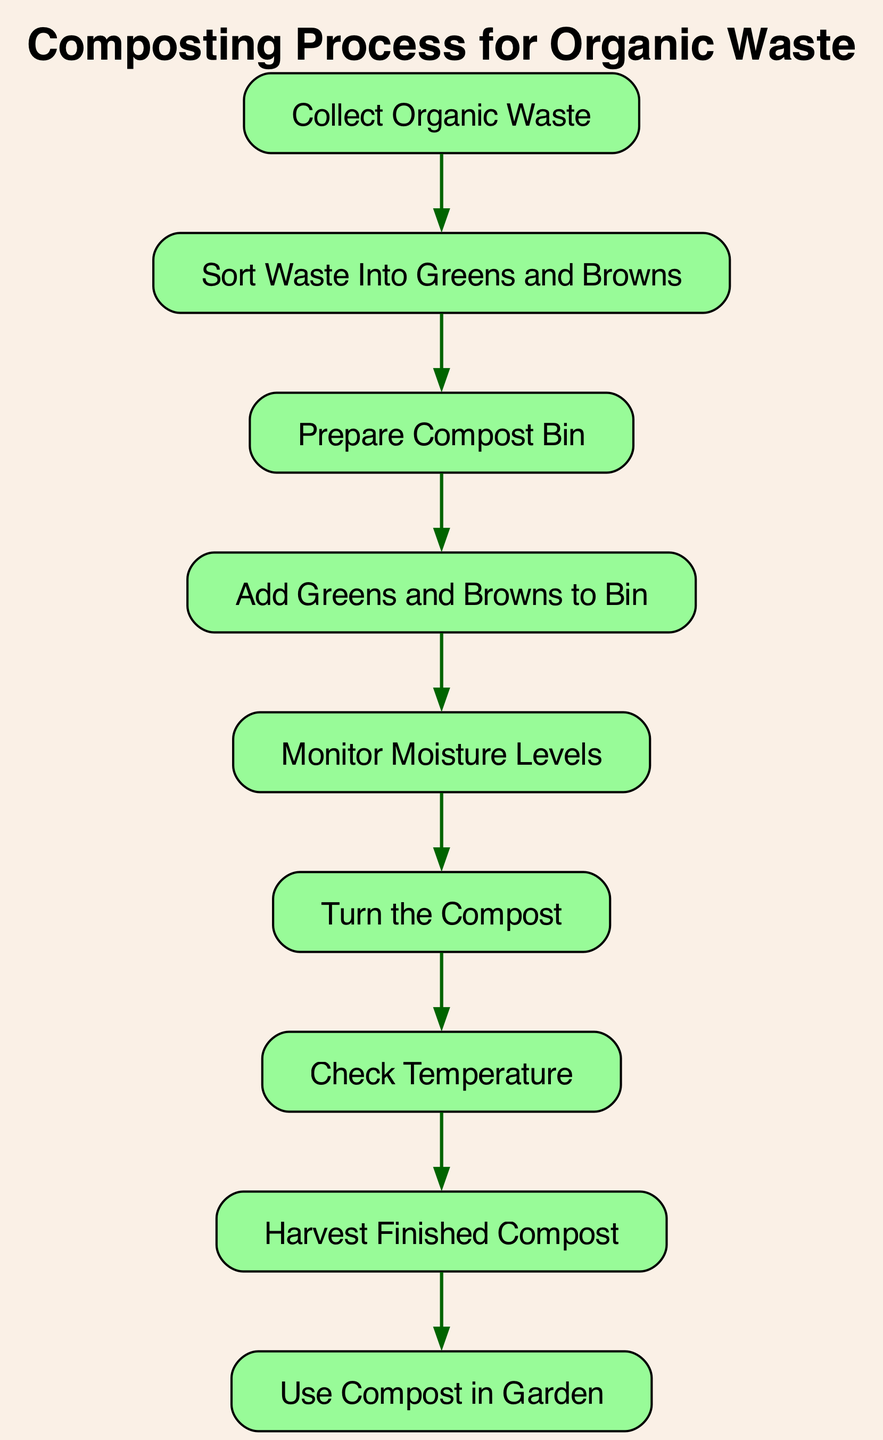What is the first activity in the composting process? The first activity listed in the diagram is "Collect Organic Waste," which is the starting point of the process.
Answer: Collect Organic Waste How many activities are included in the composting process? By counting the listed nodes in the diagram, there are a total of nine distinct activities that are part of the composting process.
Answer: Nine What is the last step in the composting process? The last activity in the flow of the diagram is "Use Compost in Garden," which concludes the process after harvesting the compost.
Answer: Use Compost in Garden Which activity follows "Sort Waste Into Greens and Browns"? The activity that follows "Sort Waste Into Greens and Browns" is "Prepare Compost Bin," indicating the next step after sorting the waste.
Answer: Prepare Compost Bin What activity involves adding materials to the compost bin? The specific activity that involves adding materials is "Add Greens and Browns to Bin," which comes after preparing the bin.
Answer: Add Greens and Browns to Bin How many transitions are there in this activity diagram? By examining the transitions between nodes in the diagram, there are a total of eight connections that show the flow from one activity to another.
Answer: Eight What activity comes before "Monitor Moisture Levels"? "Add Greens and Browns to Bin" is the activity that comes before "Monitor Moisture Levels," indicating that waste needs to be added to the bin first.
Answer: Add Greens and Browns to Bin What do you do after checking the temperature? After checking the temperature, the next step is to "Harvest Finished Compost," indicating the progression toward the final product.
Answer: Harvest Finished Compost What is the relationship between "Turn the Compost" and "Check Temperature"? "Turn the Compost" directly precedes "Check Temperature" in the sequence of activities, showing that turning the compost is necessary before checking its temperature.
Answer: Turn the Compost 